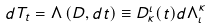<formula> <loc_0><loc_0><loc_500><loc_500>d T _ { t } = \Lambda \left ( D , d t \right ) \equiv D ^ { \iota } _ { \kappa } ( t ) d \Lambda ^ { \kappa } _ { \iota }</formula> 